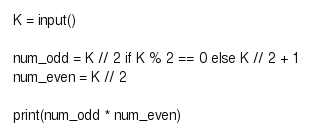<code> <loc_0><loc_0><loc_500><loc_500><_Python_>K = input()

num_odd = K // 2 if K % 2 == 0 else K // 2 + 1
num_even = K // 2

print(num_odd * num_even)</code> 